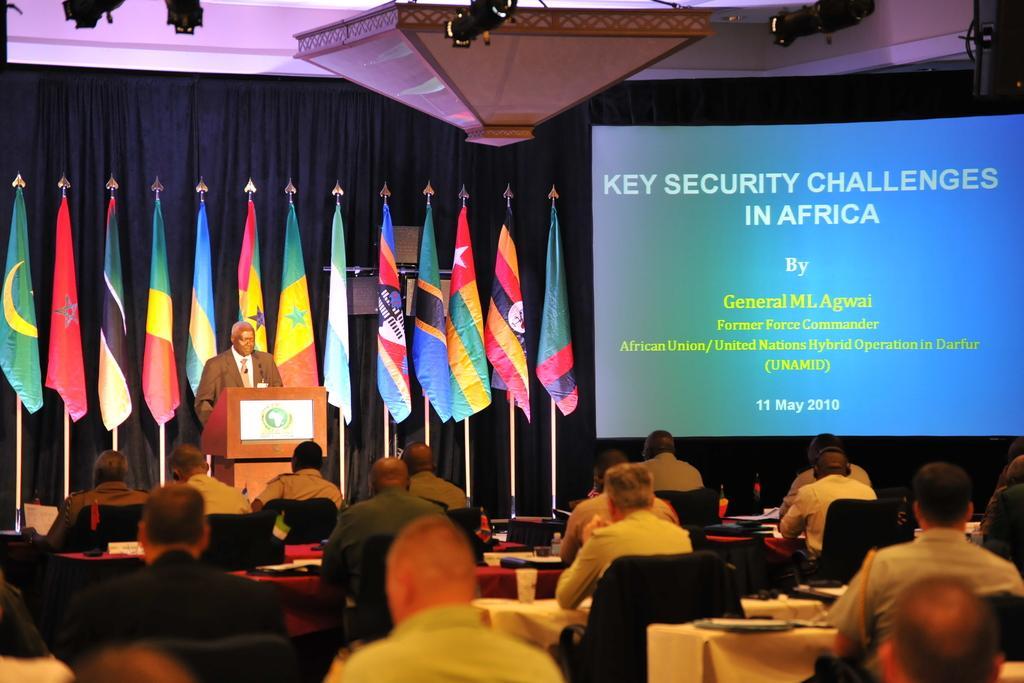Can you describe this image briefly? In this picture we can see a group of people sitting on chairs and a man standing at the podium and in the background we can see flags, screen, curtains. 